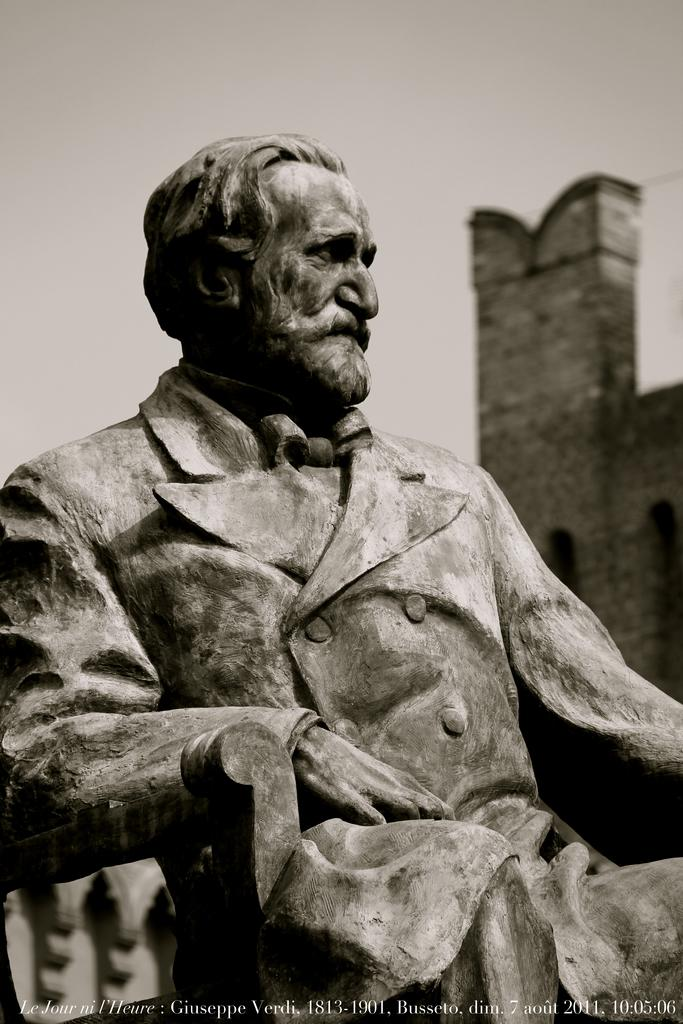What is the main subject of the image? There is a sculpture in the image. Can you describe the background of the sculpture? The background of the sculpture is blurred. What number is assigned to the card that the committee is discussing in the image? There is no card or committee present in the image; it features a sculpture with a blurred background. 